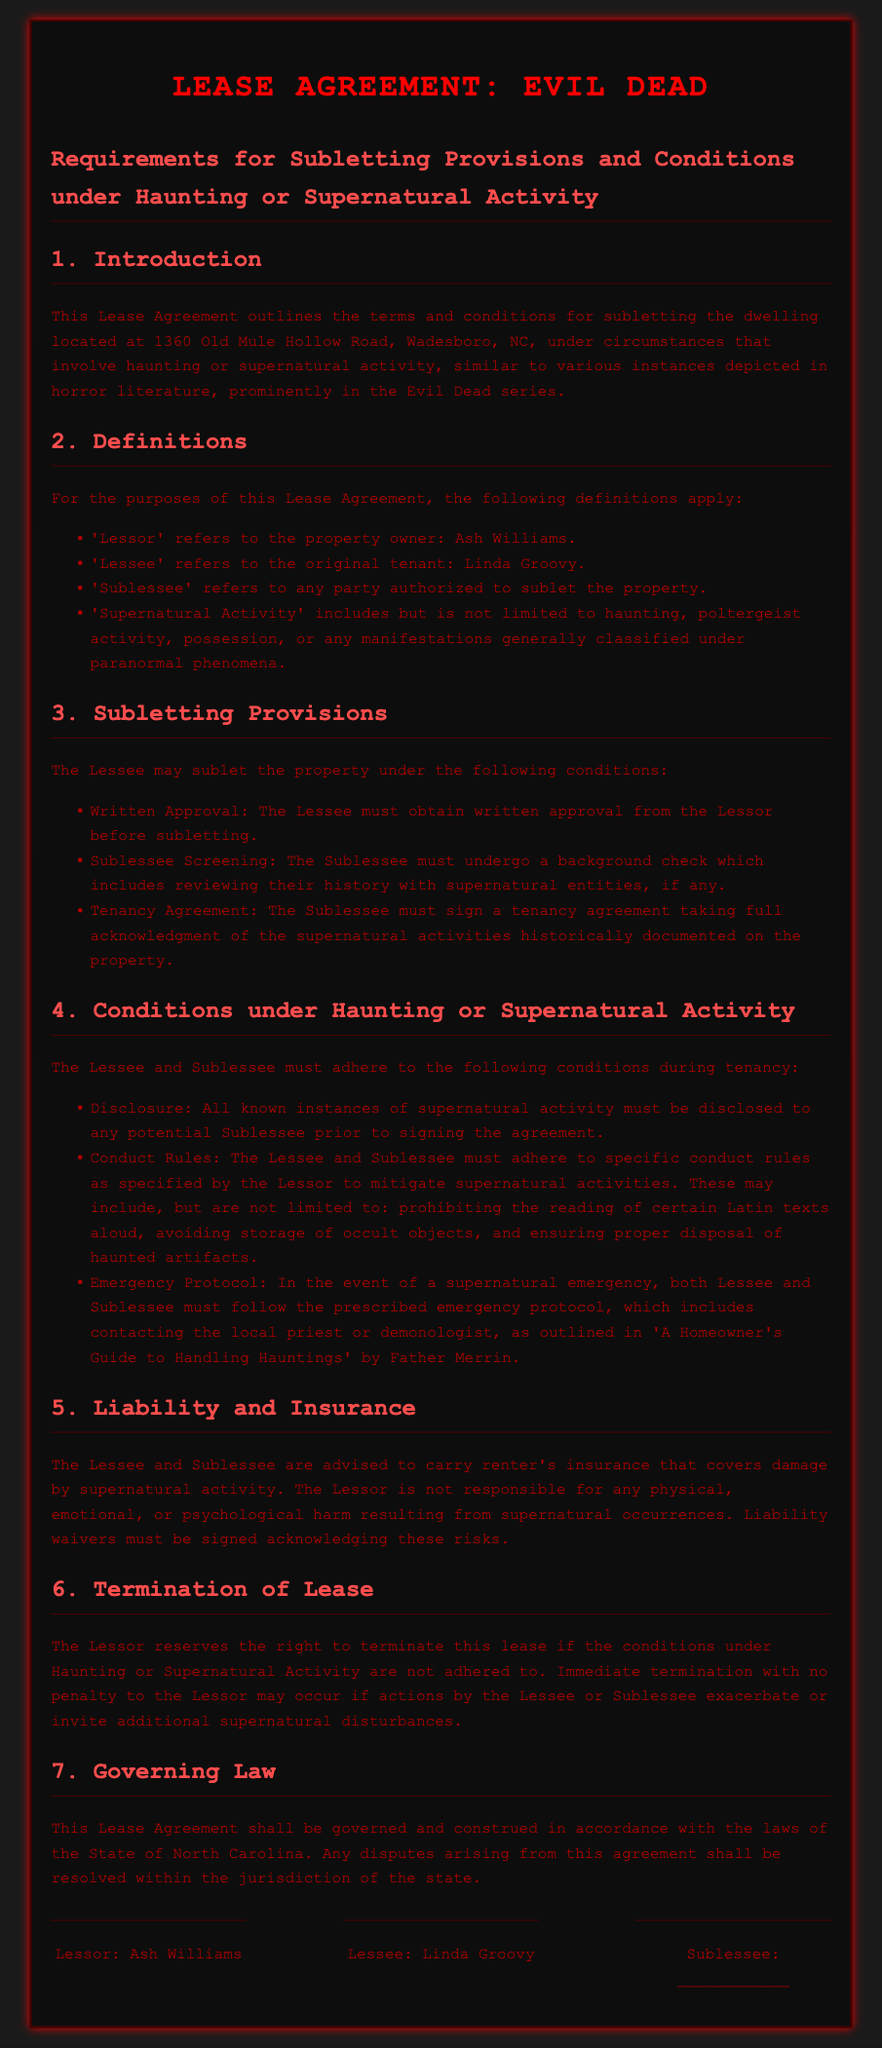What is the address of the property? The address is specified in the introduction of the document as the location for the lease agreement.
Answer: 1360 Old Mule Hollow Road, Wadesboro, NC Who is the Lessor? The Lessor is defined as the property owner in the document.
Answer: Ash Williams What must be obtained before subletting? The document states that written approval is necessary for subletting.
Answer: Written approval What type of activity must the Sublessee be screened for? The provisions require a background check related to specific types of activities.
Answer: Supernatural entities What must be disclosed to potential Sublessees? The content of the document specifies an obligation regarding known instances that must be communicated.
Answer: Supernatural activity Who must follow the emergency protocol? The document clearly states that both parties are responsible for adhering to the prescribed emergency measures.
Answer: Lessee and Sublessee What may the Lessor do if conditions are not adhered to? The consequences of non-compliance with lease conditions are laid out in the document.
Answer: Terminate the lease What insurance is advised for the Lessee and Sublessee? The document recommends a specific type of insurance to safeguard against particular incidents.
Answer: Renter's insurance What is the governing law for this lease agreement? The document outlines jurisdictional specifics referring to legal governance of the agreement.
Answer: North Carolina 